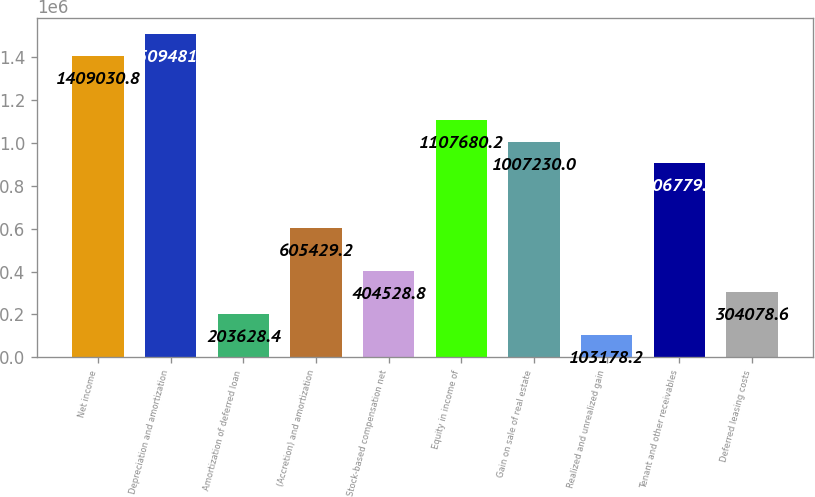Convert chart to OTSL. <chart><loc_0><loc_0><loc_500><loc_500><bar_chart><fcel>Net income<fcel>Depreciation and amortization<fcel>Amortization of deferred loan<fcel>(Accretion) and amortization<fcel>Stock-based compensation net<fcel>Equity in income of<fcel>Gain on sale of real estate<fcel>Realized and unrealized gain<fcel>Tenant and other receivables<fcel>Deferred leasing costs<nl><fcel>1.40903e+06<fcel>1.50948e+06<fcel>203628<fcel>605429<fcel>404529<fcel>1.10768e+06<fcel>1.00723e+06<fcel>103178<fcel>906780<fcel>304079<nl></chart> 